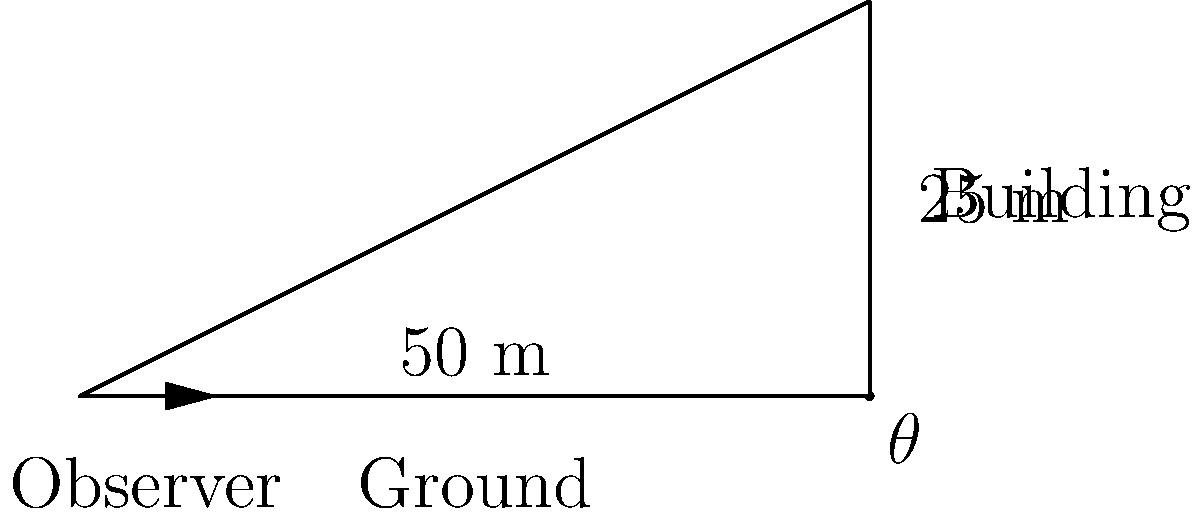You are observing insects on a rooftop garden of a tall building. The building is 50 meters away from your position and the garden is located 25 meters above ground level. What is the angle of elevation ($\theta$) required to observe the insects on the rooftop garden? To solve this problem, we'll use the tangent function from trigonometry:

1) In a right-angled triangle, $\tan(\theta) = \frac{\text{opposite}}{\text{adjacent}}$

2) In this case:
   - The opposite side is the height of the building (25 m)
   - The adjacent side is the distance from the observer to the building (50 m)

3) We can write the equation:
   $\tan(\theta) = \frac{25}{50} = \frac{1}{2} = 0.5$

4) To find $\theta$, we need to use the inverse tangent (arctan or $\tan^{-1}$):
   $\theta = \tan^{-1}(0.5)$

5) Using a calculator or trigonometric tables:
   $\theta \approx 26.57°$

Therefore, the angle of elevation required to observe the insects on the rooftop garden is approximately 26.57°.
Answer: $26.57°$ 